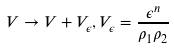Convert formula to latex. <formula><loc_0><loc_0><loc_500><loc_500>V \rightarrow V + V _ { \epsilon } , V _ { \epsilon } = \frac { \epsilon ^ { n } } { \rho _ { 1 } \rho _ { 2 } }</formula> 